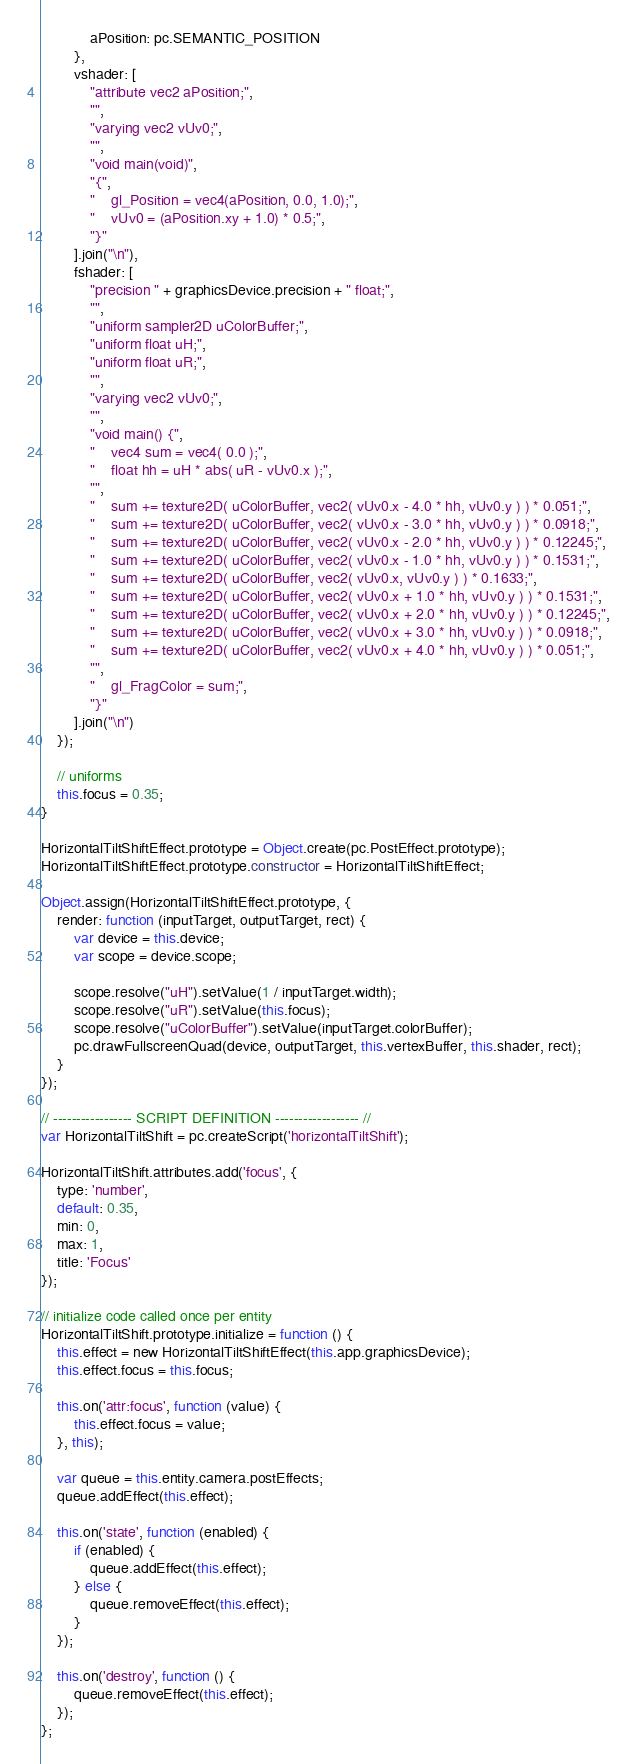<code> <loc_0><loc_0><loc_500><loc_500><_JavaScript_>            aPosition: pc.SEMANTIC_POSITION
        },
        vshader: [
            "attribute vec2 aPosition;",
            "",
            "varying vec2 vUv0;",
            "",
            "void main(void)",
            "{",
            "    gl_Position = vec4(aPosition, 0.0, 1.0);",
            "    vUv0 = (aPosition.xy + 1.0) * 0.5;",
            "}"
        ].join("\n"),
        fshader: [
            "precision " + graphicsDevice.precision + " float;",
            "",
            "uniform sampler2D uColorBuffer;",
            "uniform float uH;",
            "uniform float uR;",
            "",
            "varying vec2 vUv0;",
            "",
            "void main() {",
            "    vec4 sum = vec4( 0.0 );",
            "    float hh = uH * abs( uR - vUv0.x );",
            "",
            "    sum += texture2D( uColorBuffer, vec2( vUv0.x - 4.0 * hh, vUv0.y ) ) * 0.051;",
            "    sum += texture2D( uColorBuffer, vec2( vUv0.x - 3.0 * hh, vUv0.y ) ) * 0.0918;",
            "    sum += texture2D( uColorBuffer, vec2( vUv0.x - 2.0 * hh, vUv0.y ) ) * 0.12245;",
            "    sum += texture2D( uColorBuffer, vec2( vUv0.x - 1.0 * hh, vUv0.y ) ) * 0.1531;",
            "    sum += texture2D( uColorBuffer, vec2( vUv0.x, vUv0.y ) ) * 0.1633;",
            "    sum += texture2D( uColorBuffer, vec2( vUv0.x + 1.0 * hh, vUv0.y ) ) * 0.1531;",
            "    sum += texture2D( uColorBuffer, vec2( vUv0.x + 2.0 * hh, vUv0.y ) ) * 0.12245;",
            "    sum += texture2D( uColorBuffer, vec2( vUv0.x + 3.0 * hh, vUv0.y ) ) * 0.0918;",
            "    sum += texture2D( uColorBuffer, vec2( vUv0.x + 4.0 * hh, vUv0.y ) ) * 0.051;",
            "",
            "    gl_FragColor = sum;",
            "}"
        ].join("\n")
    });

    // uniforms
    this.focus = 0.35;
}

HorizontalTiltShiftEffect.prototype = Object.create(pc.PostEffect.prototype);
HorizontalTiltShiftEffect.prototype.constructor = HorizontalTiltShiftEffect;

Object.assign(HorizontalTiltShiftEffect.prototype, {
    render: function (inputTarget, outputTarget, rect) {
        var device = this.device;
        var scope = device.scope;

        scope.resolve("uH").setValue(1 / inputTarget.width);
        scope.resolve("uR").setValue(this.focus);
        scope.resolve("uColorBuffer").setValue(inputTarget.colorBuffer);
        pc.drawFullscreenQuad(device, outputTarget, this.vertexBuffer, this.shader, rect);
    }
});

// ----------------- SCRIPT DEFINITION ------------------ //
var HorizontalTiltShift = pc.createScript('horizontalTiltShift');

HorizontalTiltShift.attributes.add('focus', {
    type: 'number',
    default: 0.35,
    min: 0,
    max: 1,
    title: 'Focus'
});

// initialize code called once per entity
HorizontalTiltShift.prototype.initialize = function () {
    this.effect = new HorizontalTiltShiftEffect(this.app.graphicsDevice);
    this.effect.focus = this.focus;

    this.on('attr:focus', function (value) {
        this.effect.focus = value;
    }, this);

    var queue = this.entity.camera.postEffects;
    queue.addEffect(this.effect);

    this.on('state', function (enabled) {
        if (enabled) {
            queue.addEffect(this.effect);
        } else {
            queue.removeEffect(this.effect);
        }
    });

    this.on('destroy', function () {
        queue.removeEffect(this.effect);
    });
};
</code> 